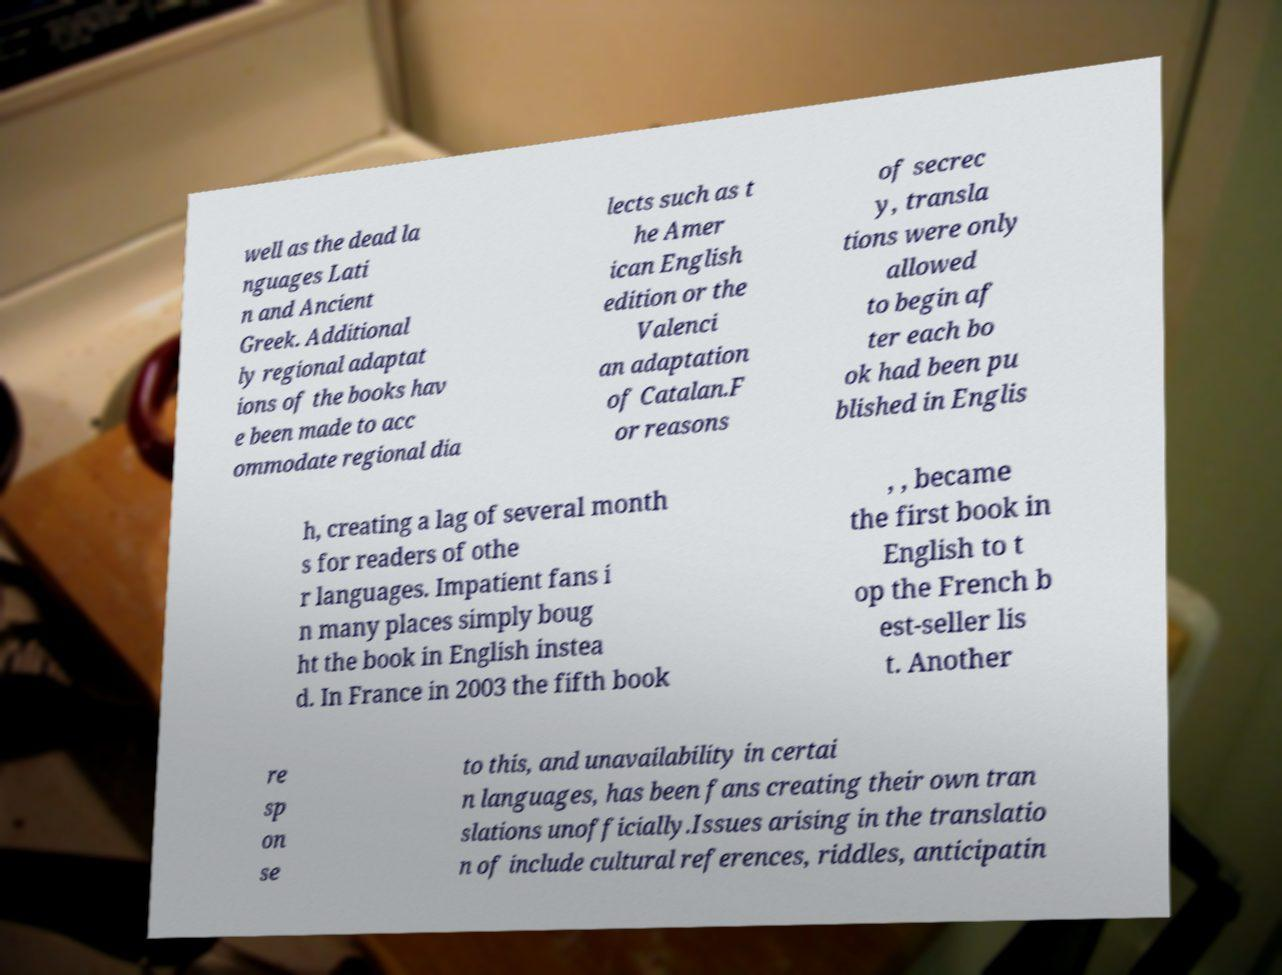I need the written content from this picture converted into text. Can you do that? well as the dead la nguages Lati n and Ancient Greek. Additional ly regional adaptat ions of the books hav e been made to acc ommodate regional dia lects such as t he Amer ican English edition or the Valenci an adaptation of Catalan.F or reasons of secrec y, transla tions were only allowed to begin af ter each bo ok had been pu blished in Englis h, creating a lag of several month s for readers of othe r languages. Impatient fans i n many places simply boug ht the book in English instea d. In France in 2003 the fifth book , , became the first book in English to t op the French b est-seller lis t. Another re sp on se to this, and unavailability in certai n languages, has been fans creating their own tran slations unofficially.Issues arising in the translatio n of include cultural references, riddles, anticipatin 